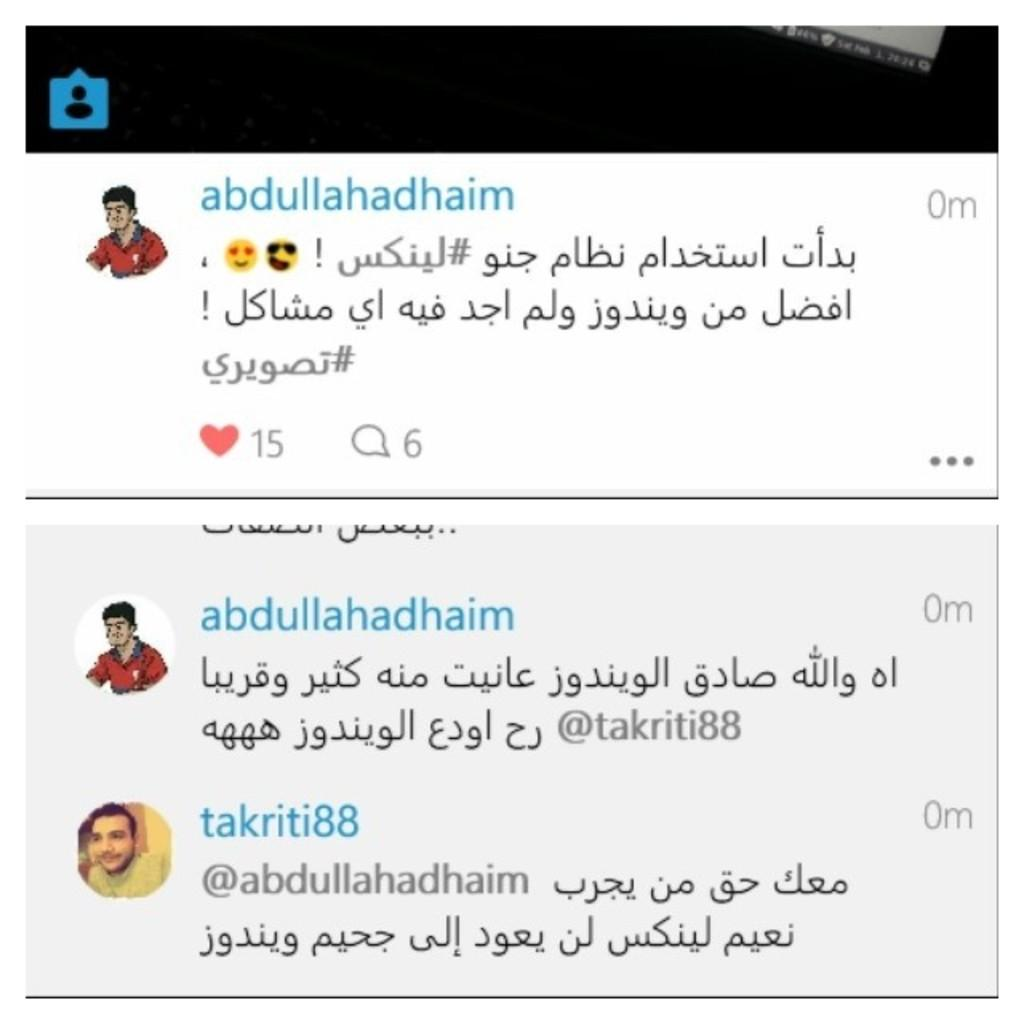What type of content is displayed in the image? The image contains screenshots of comments and messages. Can you describe the visual elements associated with the comments and messages? Profile pictures are present in the image alongside the comments and messages. How many tickets are visible in the image? There are no tickets present in the image; it contains screenshots of comments and messages. What type of explosive device can be seen in the image? There is no explosive device present in the image. 